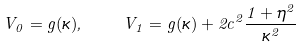<formula> <loc_0><loc_0><loc_500><loc_500>V _ { 0 } = g ( \kappa ) , \quad V _ { 1 } = g ( \kappa ) + 2 c ^ { 2 } \frac { 1 + \eta ^ { 2 } } { \kappa ^ { 2 } }</formula> 